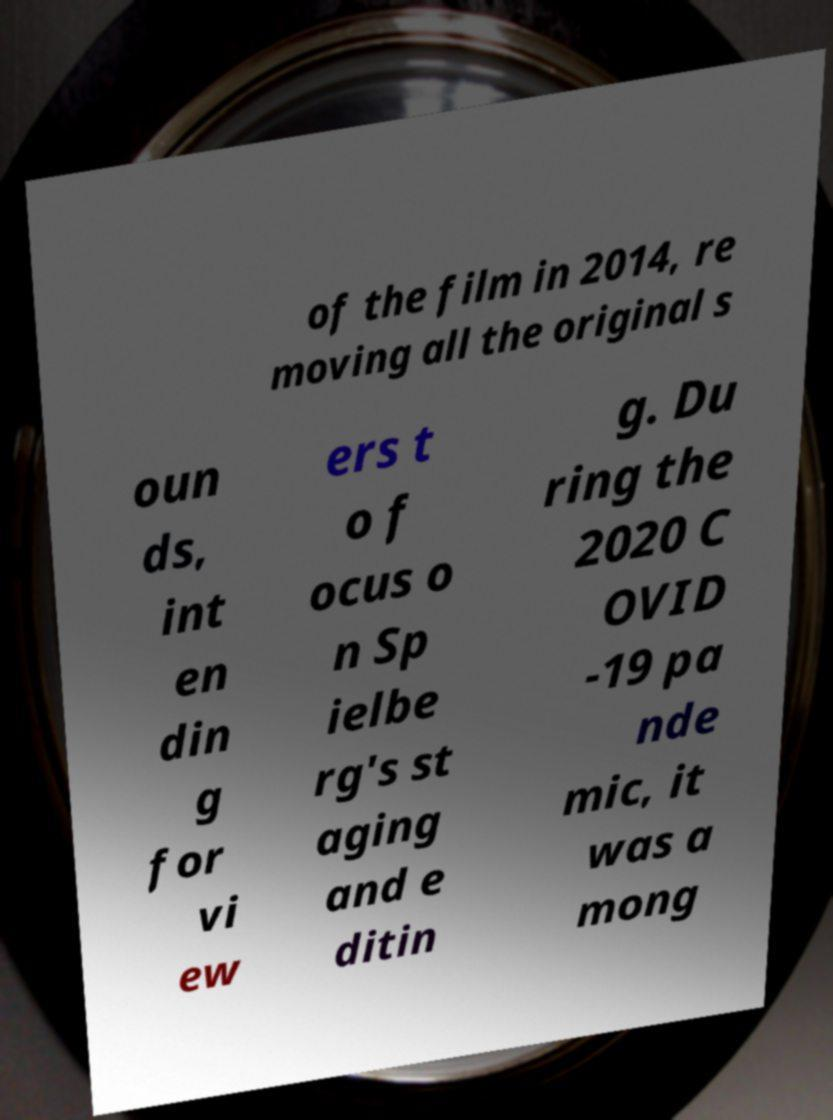There's text embedded in this image that I need extracted. Can you transcribe it verbatim? of the film in 2014, re moving all the original s oun ds, int en din g for vi ew ers t o f ocus o n Sp ielbe rg's st aging and e ditin g. Du ring the 2020 C OVID -19 pa nde mic, it was a mong 